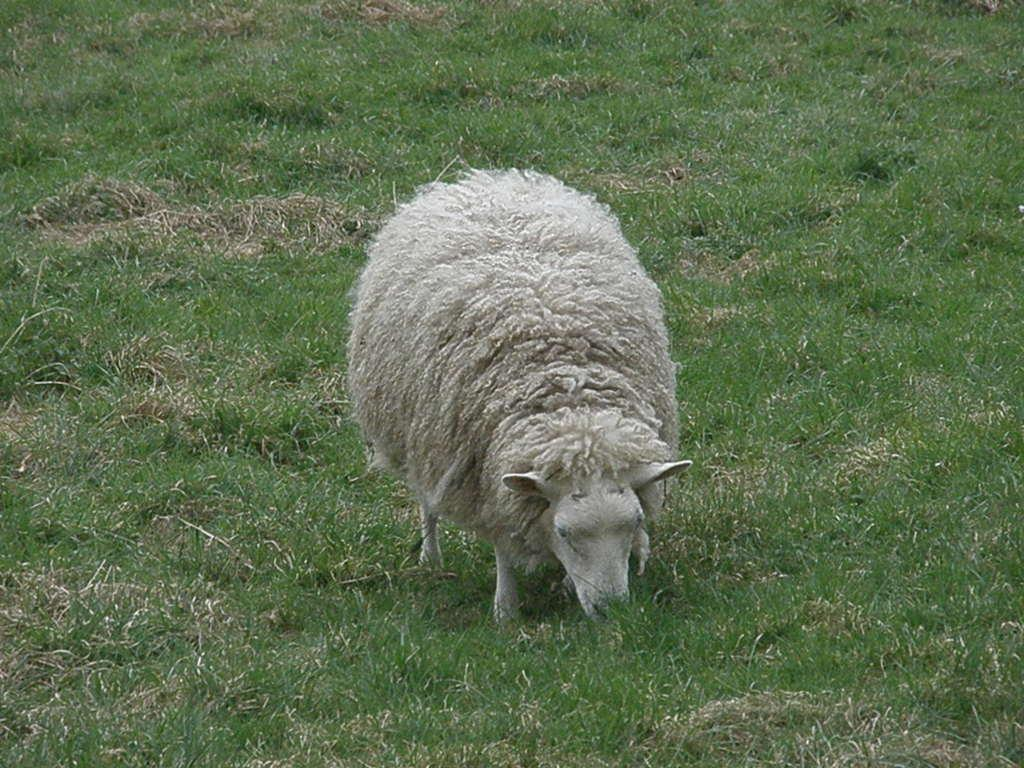What type of vegetation is present on the ground in the image? There is grass on the ground in the image. What animal can be seen in the image? There is a sheep in the image. Where is the sheep located in relation to the grass? The sheep is standing in the grass. What is the sheep doing in the image? The sheep is eating the grass. What type of game is being played in the image? There is no game being played in the image; it features a sheep eating grass. Is there a ghost visible in the image? There is no ghost present in the image. 